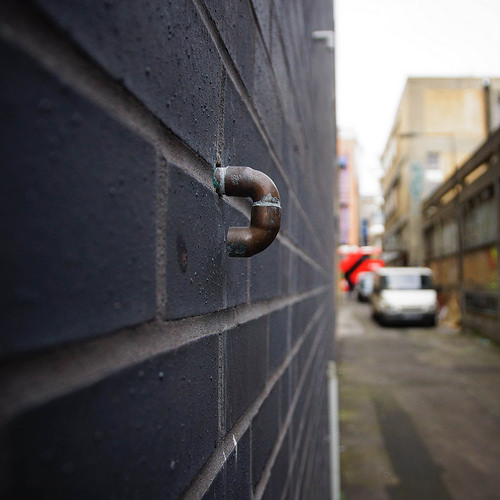<image>
Is there a elbow next to the windshield? No. The elbow is not positioned next to the windshield. They are located in different areas of the scene. Is there a pipe next to the wall? No. The pipe is not positioned next to the wall. They are located in different areas of the scene. 